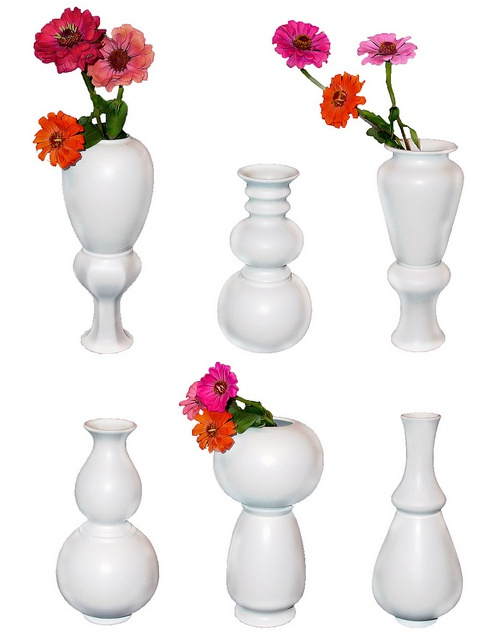Describe the objects in this image and their specific colors. I can see vase in white, lightgray, and darkgray tones, vase in white, lightgray, and darkgray tones, vase in white, lightgray, and darkgray tones, vase in white, lightgray, and darkgray tones, and vase in white, lightgray, and darkgray tones in this image. 